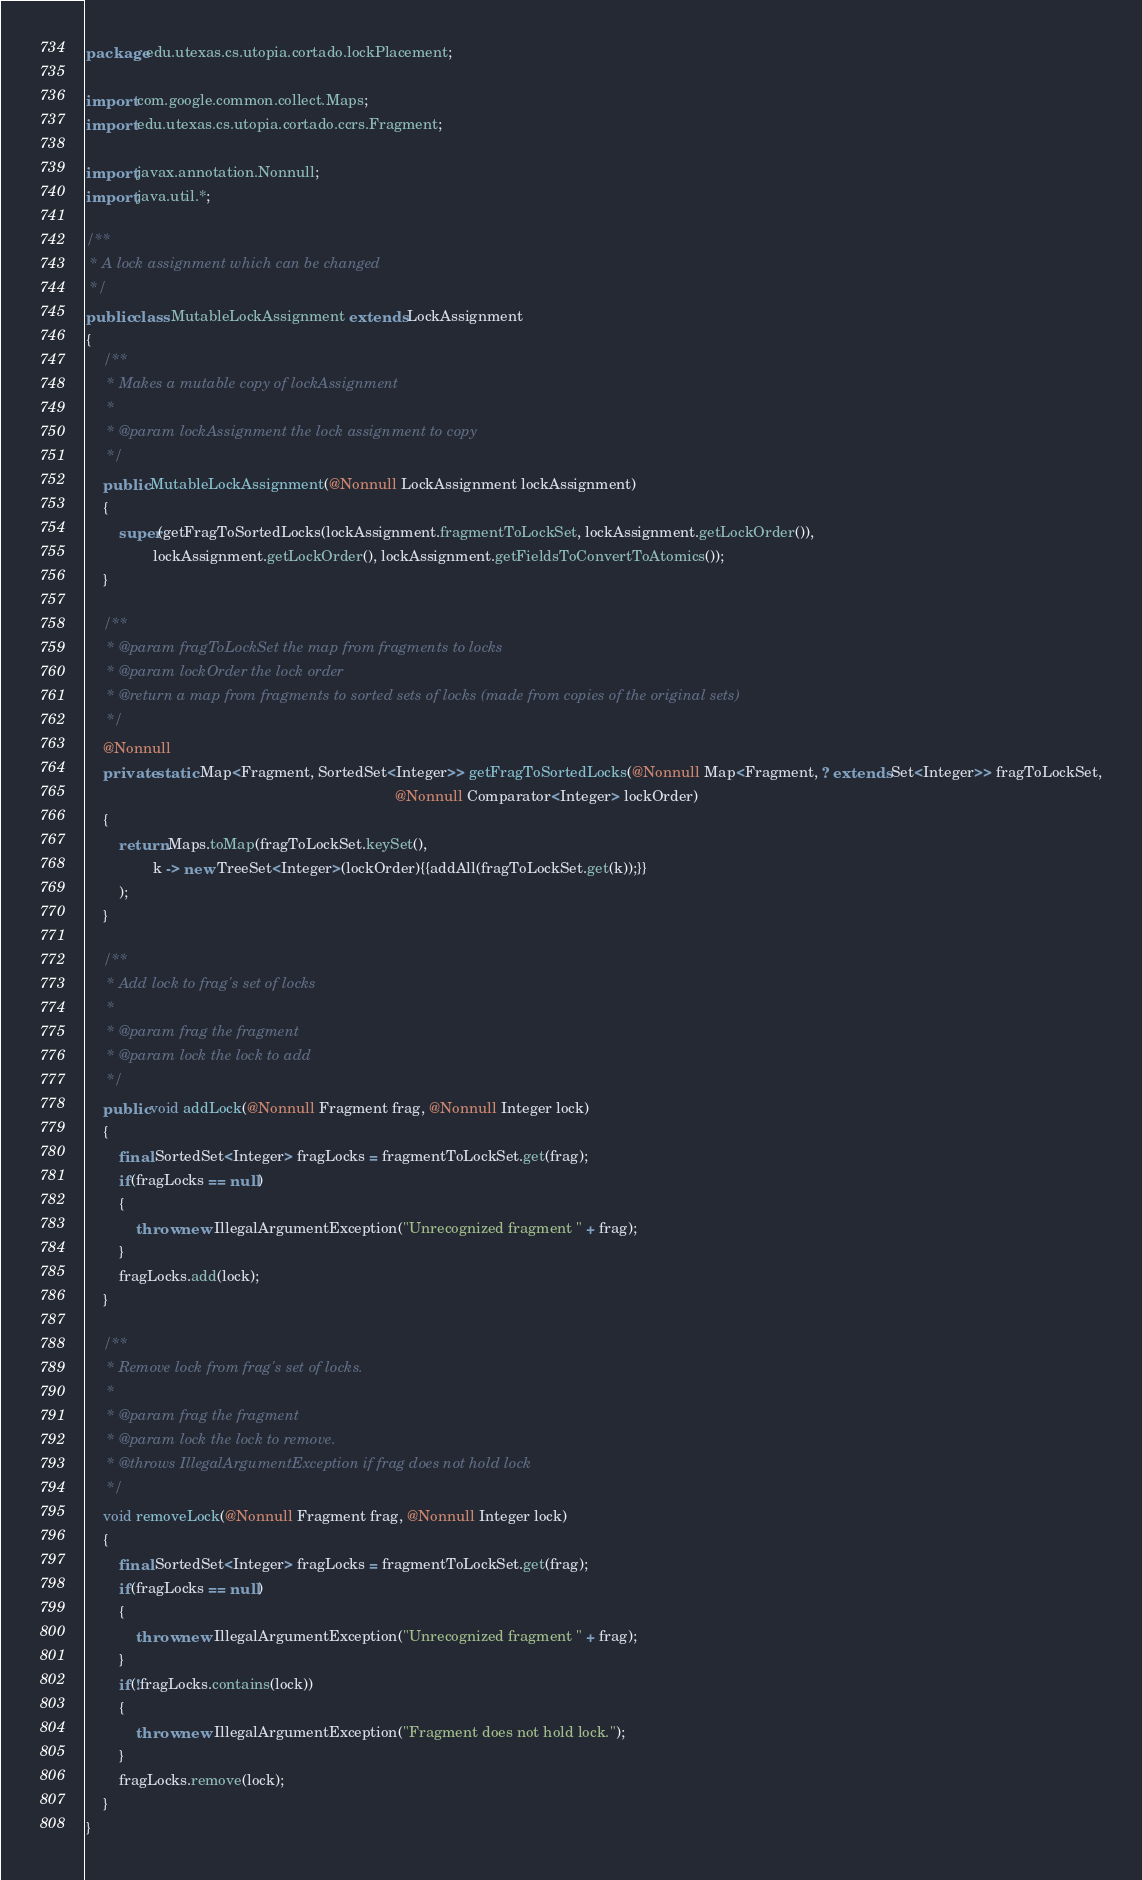<code> <loc_0><loc_0><loc_500><loc_500><_Java_>package edu.utexas.cs.utopia.cortado.lockPlacement;

import com.google.common.collect.Maps;
import edu.utexas.cs.utopia.cortado.ccrs.Fragment;

import javax.annotation.Nonnull;
import java.util.*;

/**
 * A lock assignment which can be changed
 */
public class MutableLockAssignment extends LockAssignment
{
    /**
     * Makes a mutable copy of lockAssignment
     *
     * @param lockAssignment the lock assignment to copy
     */
    public MutableLockAssignment(@Nonnull LockAssignment lockAssignment)
    {
        super(getFragToSortedLocks(lockAssignment.fragmentToLockSet, lockAssignment.getLockOrder()),
                lockAssignment.getLockOrder(), lockAssignment.getFieldsToConvertToAtomics());
    }

    /**
     * @param fragToLockSet the map from fragments to locks
     * @param lockOrder the lock order
     * @return a map from fragments to sorted sets of locks (made from copies of the original sets)
     */
    @Nonnull
    private static Map<Fragment, SortedSet<Integer>> getFragToSortedLocks(@Nonnull Map<Fragment, ? extends Set<Integer>> fragToLockSet,
                                                                          @Nonnull Comparator<Integer> lockOrder)
    {
        return Maps.toMap(fragToLockSet.keySet(),
                k -> new TreeSet<Integer>(lockOrder){{addAll(fragToLockSet.get(k));}}
        );
    }

    /**
     * Add lock to frag's set of locks
     *
     * @param frag the fragment
     * @param lock the lock to add
     */
    public void addLock(@Nonnull Fragment frag, @Nonnull Integer lock)
    {
        final SortedSet<Integer> fragLocks = fragmentToLockSet.get(frag);
        if(fragLocks == null)
        {
            throw new IllegalArgumentException("Unrecognized fragment " + frag);
        }
        fragLocks.add(lock);
    }

    /**
     * Remove lock from frag's set of locks.
     *
     * @param frag the fragment
     * @param lock the lock to remove.
     * @throws IllegalArgumentException if frag does not hold lock
     */
    void removeLock(@Nonnull Fragment frag, @Nonnull Integer lock)
    {
        final SortedSet<Integer> fragLocks = fragmentToLockSet.get(frag);
        if(fragLocks == null)
        {
            throw new IllegalArgumentException("Unrecognized fragment " + frag);
        }
        if(!fragLocks.contains(lock))
        {
            throw new IllegalArgumentException("Fragment does not hold lock.");
        }
        fragLocks.remove(lock);
    }
}
</code> 